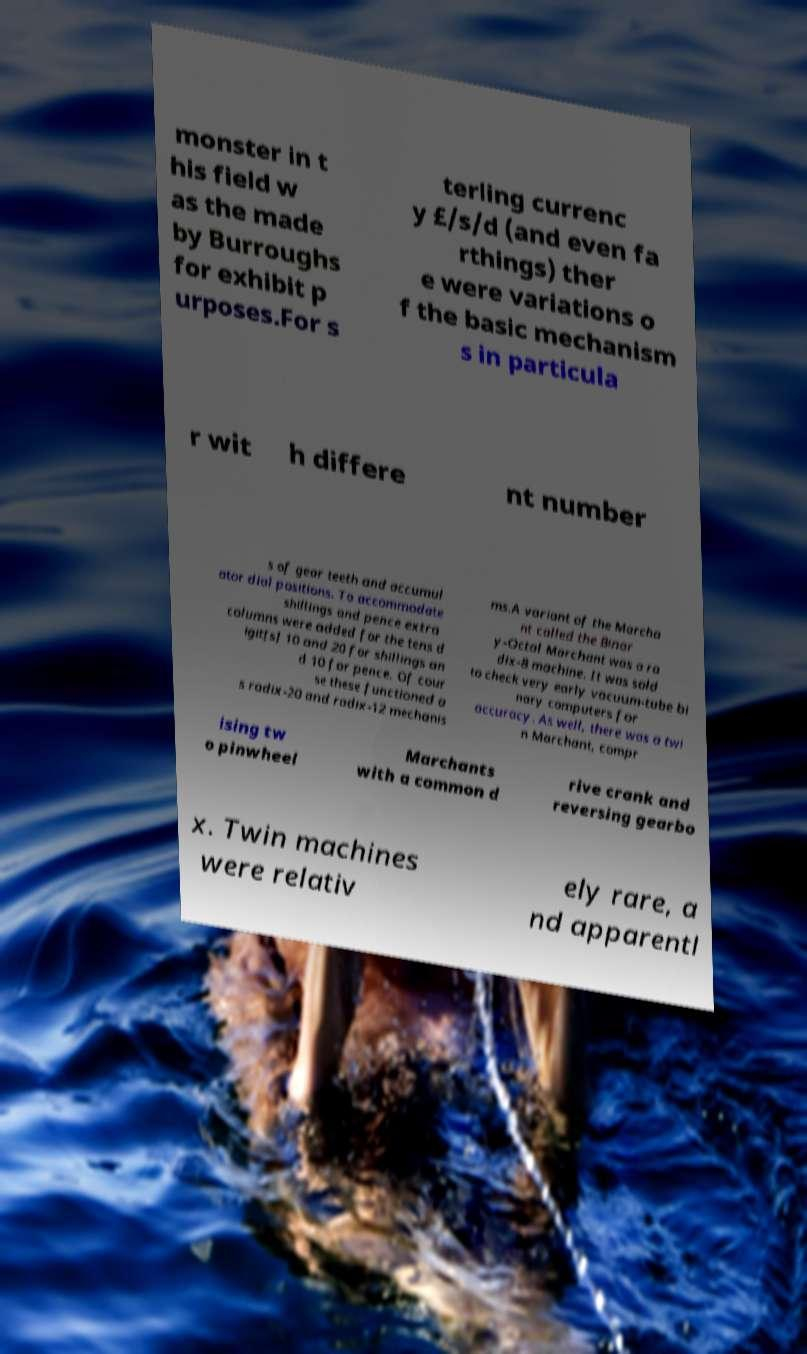There's text embedded in this image that I need extracted. Can you transcribe it verbatim? monster in t his field w as the made by Burroughs for exhibit p urposes.For s terling currenc y £/s/d (and even fa rthings) ther e were variations o f the basic mechanism s in particula r wit h differe nt number s of gear teeth and accumul ator dial positions. To accommodate shillings and pence extra columns were added for the tens d igit[s] 10 and 20 for shillings an d 10 for pence. Of cour se these functioned a s radix-20 and radix-12 mechanis ms.A variant of the Marcha nt called the Binar y-Octal Marchant was a ra dix-8 machine. It was sold to check very early vacuum-tube bi nary computers for accuracy. As well, there was a twi n Marchant, compr ising tw o pinwheel Marchants with a common d rive crank and reversing gearbo x. Twin machines were relativ ely rare, a nd apparentl 